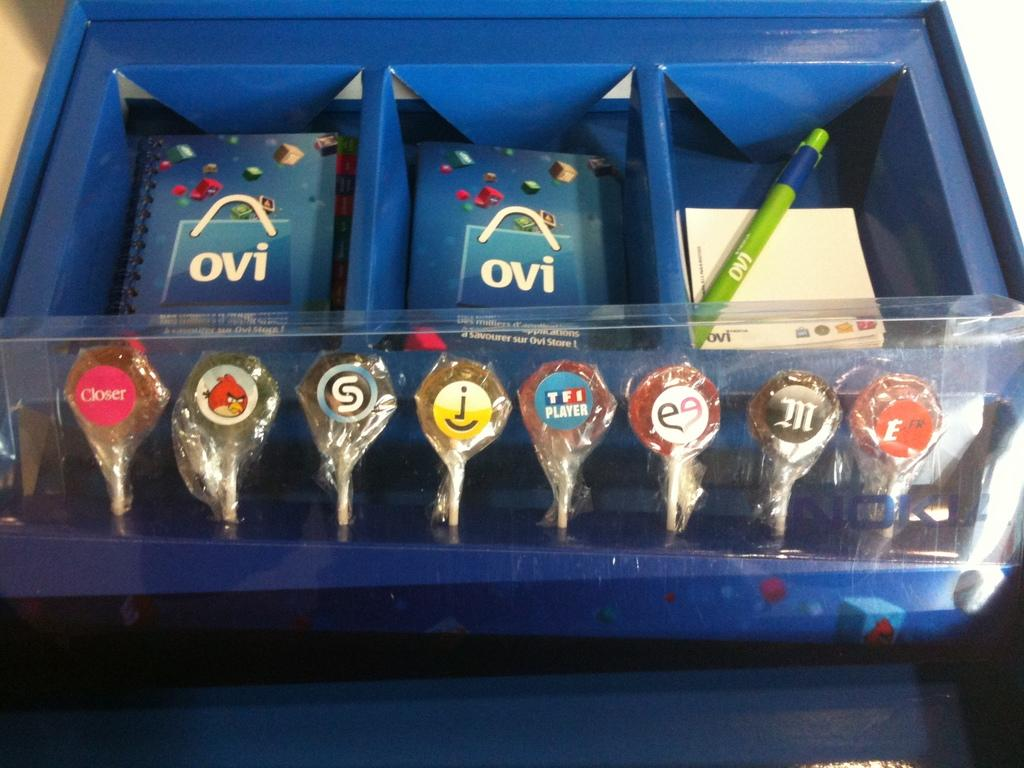<image>
Present a compact description of the photo's key features. a blue box with a green pen saying OVI on it 